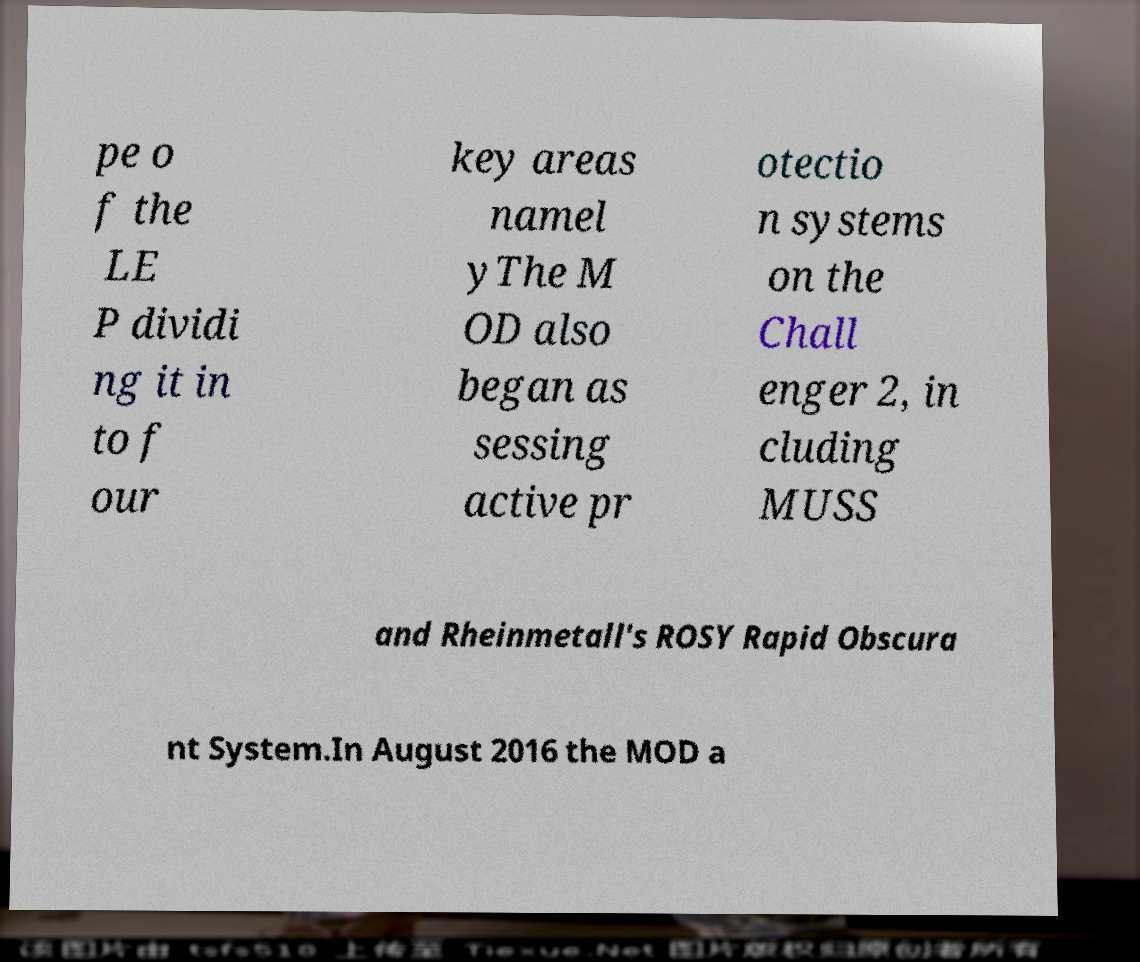What messages or text are displayed in this image? I need them in a readable, typed format. pe o f the LE P dividi ng it in to f our key areas namel yThe M OD also began as sessing active pr otectio n systems on the Chall enger 2, in cluding MUSS and Rheinmetall's ROSY Rapid Obscura nt System.In August 2016 the MOD a 